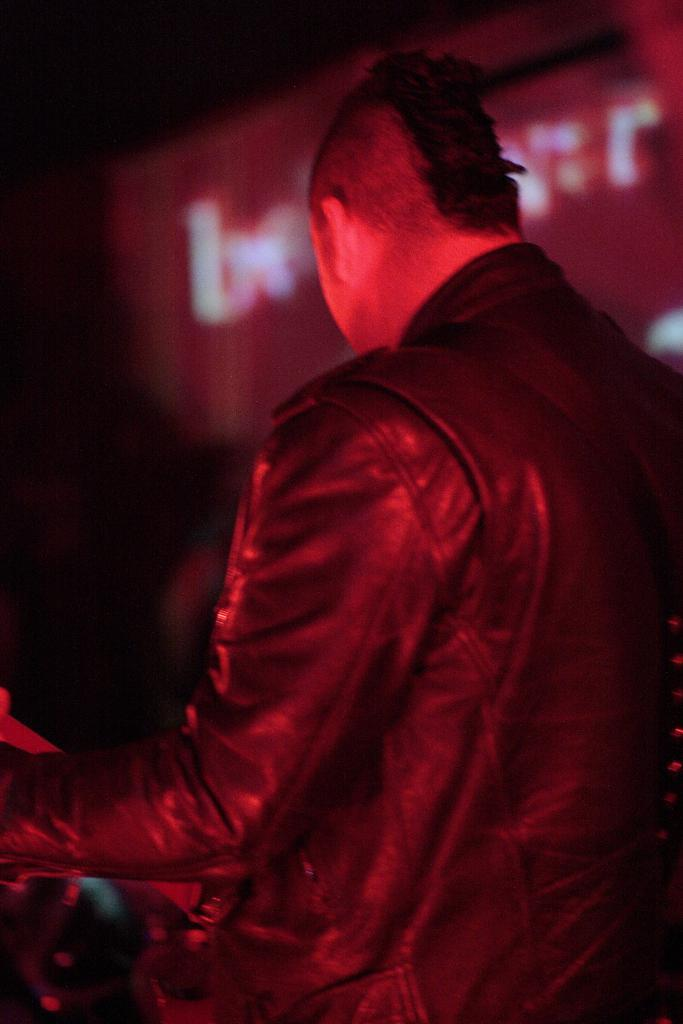Who is present in the image? There is a man in the image. What is the man wearing? The man is wearing a jacket. What is the overall color tone of the image? The image has a red color tone. How would you describe the background of the image? The background of the image is slightly blurry. How many girls are riding the train in the image? There are no girls or trains present in the image. 